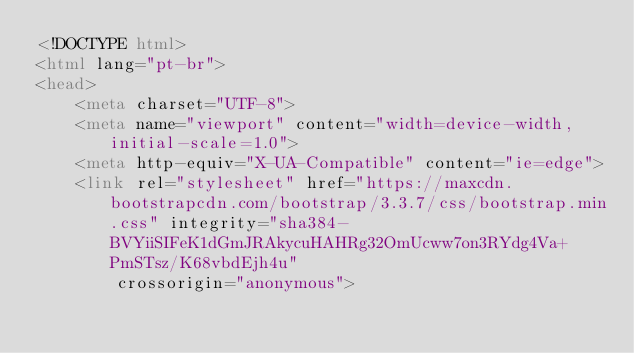<code> <loc_0><loc_0><loc_500><loc_500><_HTML_><!DOCTYPE html>
<html lang="pt-br">
<head>
    <meta charset="UTF-8">
    <meta name="viewport" content="width=device-width, initial-scale=1.0">
    <meta http-equiv="X-UA-Compatible" content="ie=edge">
    <link rel="stylesheet" href="https://maxcdn.bootstrapcdn.com/bootstrap/3.3.7/css/bootstrap.min.css" integrity="sha384-BVYiiSIFeK1dGmJRAkycuHAHRg32OmUcww7on3RYdg4Va+PmSTsz/K68vbdEjh4u"
        crossorigin="anonymous"></code> 